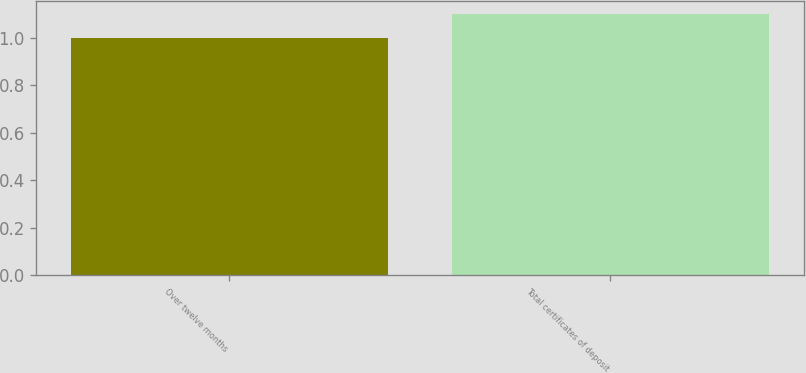<chart> <loc_0><loc_0><loc_500><loc_500><bar_chart><fcel>Over twelve months<fcel>Total certificates of deposit<nl><fcel>1<fcel>1.1<nl></chart> 